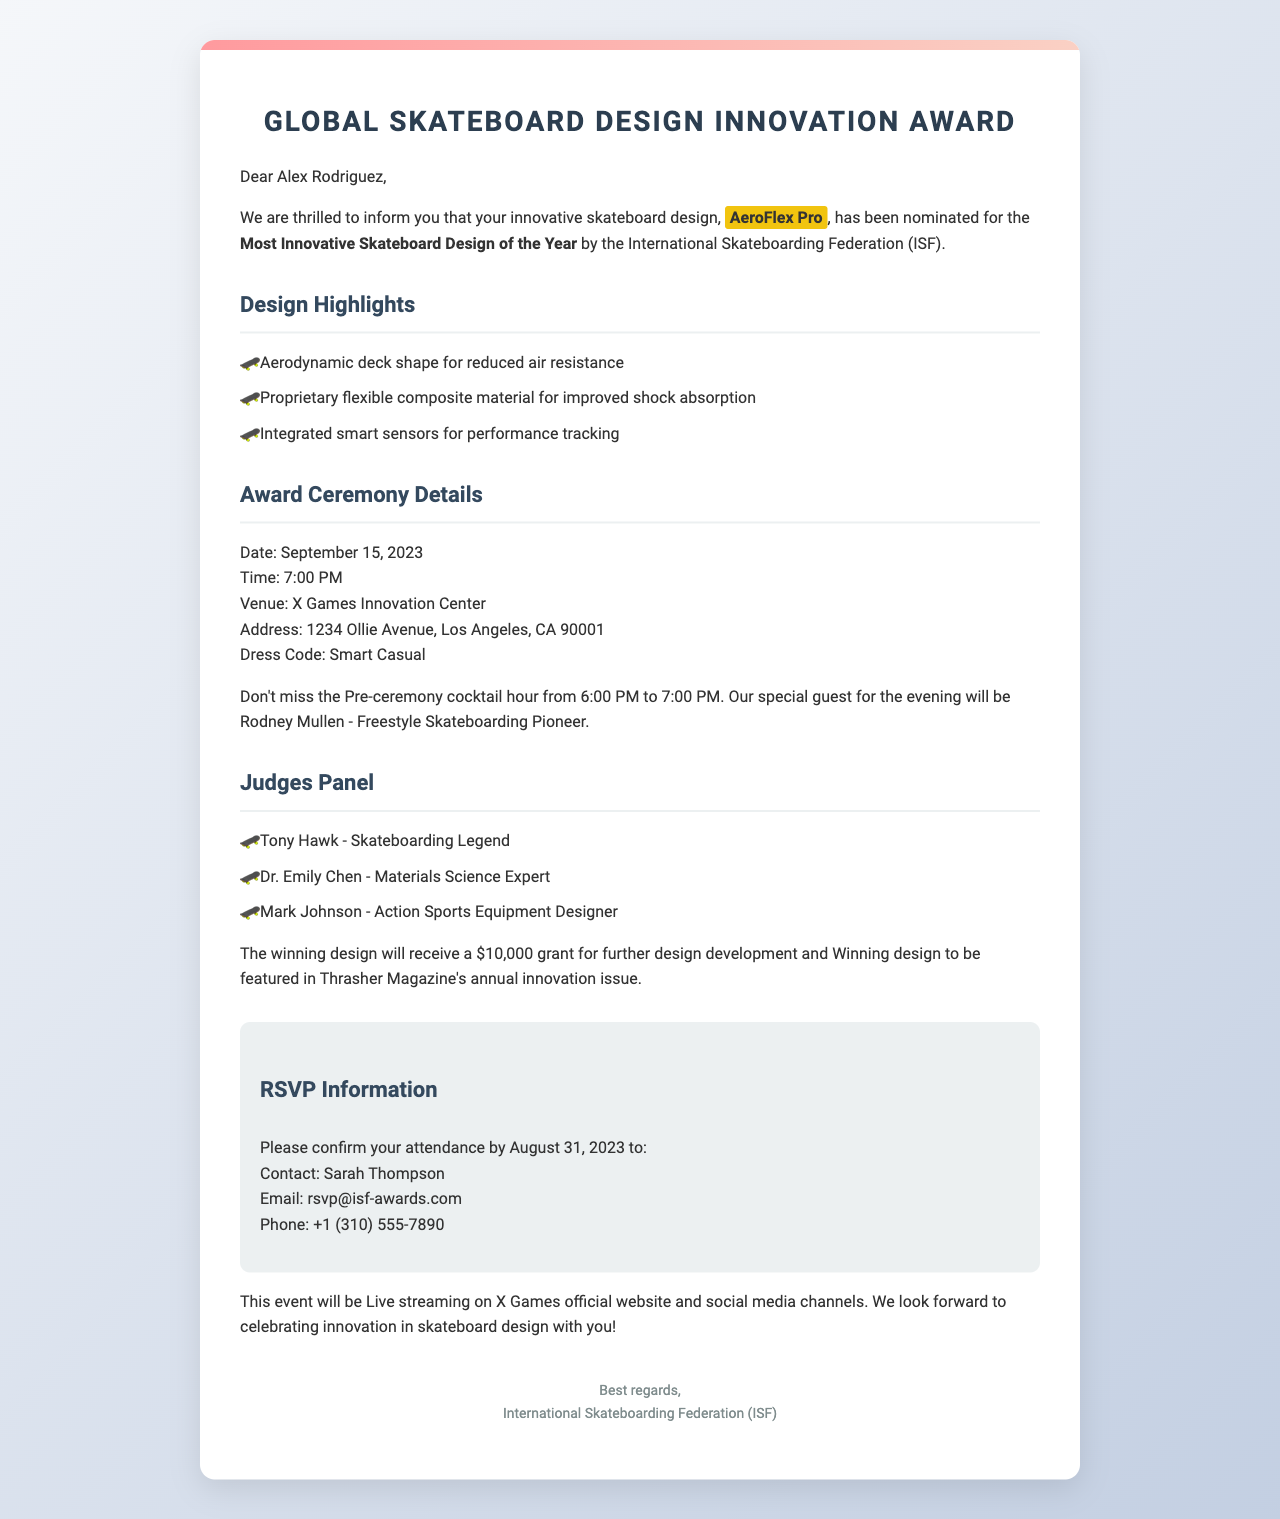What is the award name? The award name is stated at the beginning of the document.
Answer: Global Skateboard Design Innovation Award Who nominated the design? The nominating organization is mentioned in the letter.
Answer: International Skateboarding Federation (ISF) What is the date of the ceremony? The ceremony date is specified in the event details section.
Answer: September 15, 2023 What is the grand prize for the winning design? The award prize is detailed towards the end of the letter.
Answer: $10,000 grant for further design development What are the design highlights? The design highlights are listed in a specific section of the document.
Answer: Aerodynamic deck shape for reduced air resistance, Proprietary flexible composite material for improved shock absorption, Integrated smart sensors for performance tracking What is the dress code for the event? The dress code is clearly listed in the ceremony details section.
Answer: Smart Casual Who is the special guest at the ceremony? The special guest is mentioned in the networking opportunity section.
Answer: Rodney Mullen When is the RSVP deadline? The RSVP deadline is specified in the RSVP information section.
Answer: August 31, 2023 What type of coverage will the event have? Media coverage details are provided towards the end of the letter.
Answer: Live streaming on X Games official website and social media channels 